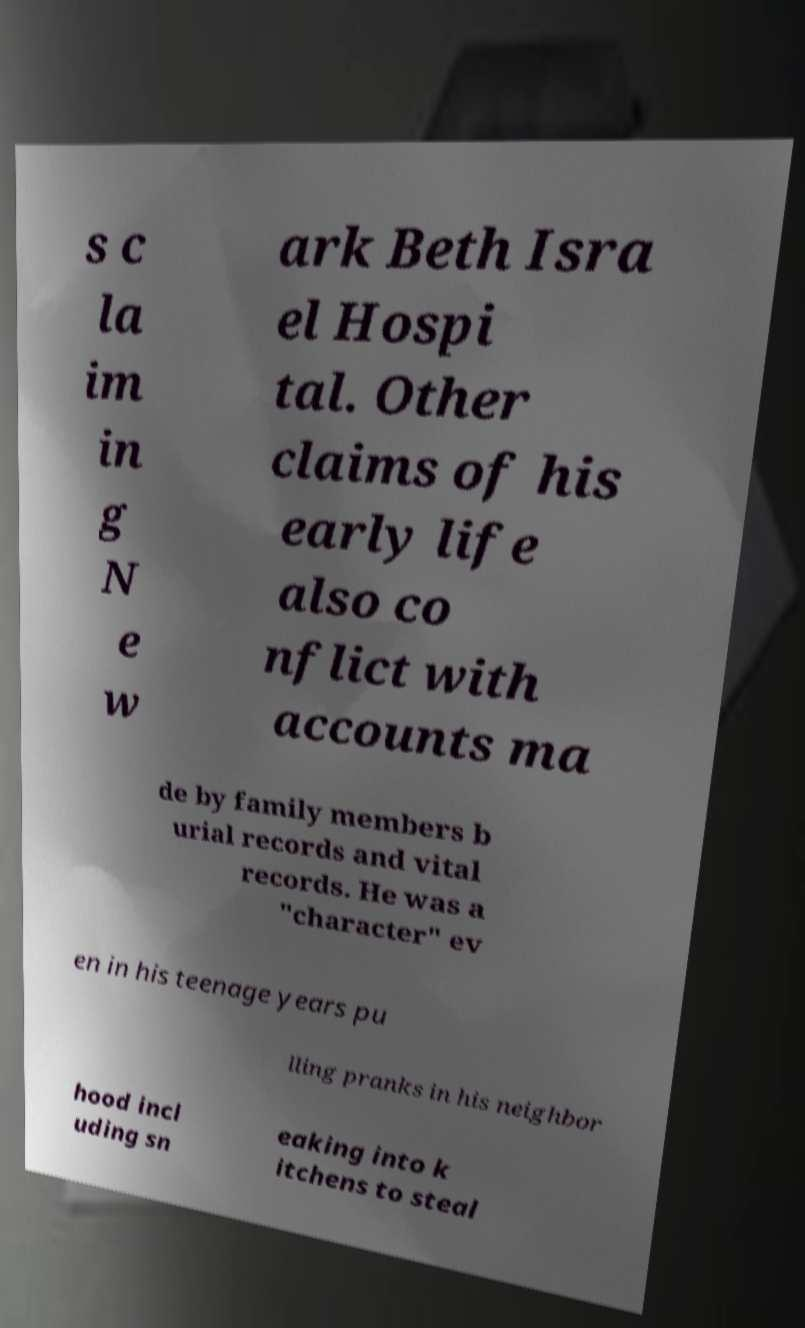For documentation purposes, I need the text within this image transcribed. Could you provide that? s c la im in g N e w ark Beth Isra el Hospi tal. Other claims of his early life also co nflict with accounts ma de by family members b urial records and vital records. He was a "character" ev en in his teenage years pu lling pranks in his neighbor hood incl uding sn eaking into k itchens to steal 